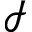Convert formula to latex. <formula><loc_0><loc_0><loc_500><loc_500>\mathcal { I }</formula> 